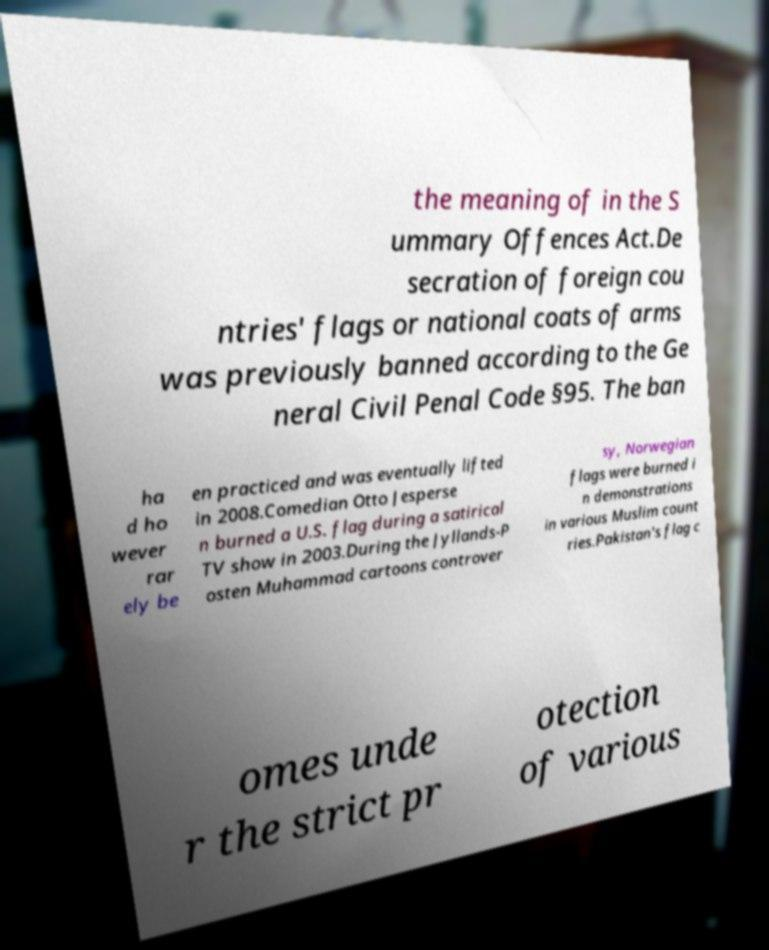I need the written content from this picture converted into text. Can you do that? the meaning of in the S ummary Offences Act.De secration of foreign cou ntries' flags or national coats of arms was previously banned according to the Ge neral Civil Penal Code §95. The ban ha d ho wever rar ely be en practiced and was eventually lifted in 2008.Comedian Otto Jesperse n burned a U.S. flag during a satirical TV show in 2003.During the Jyllands-P osten Muhammad cartoons controver sy, Norwegian flags were burned i n demonstrations in various Muslim count ries.Pakistan's flag c omes unde r the strict pr otection of various 